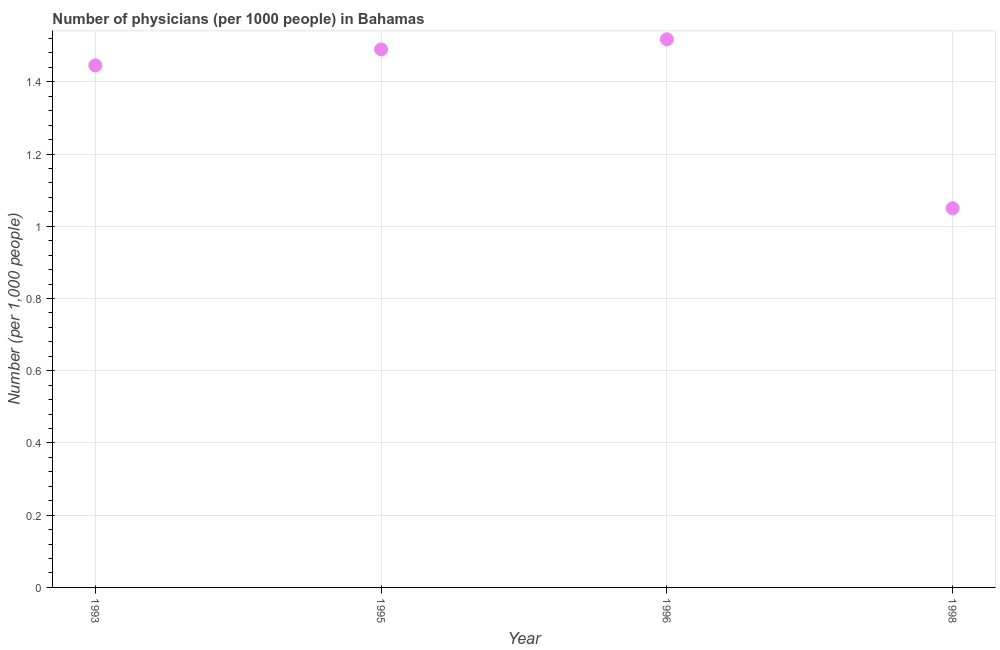What is the number of physicians in 1993?
Offer a terse response. 1.45. Across all years, what is the maximum number of physicians?
Provide a short and direct response. 1.52. What is the sum of the number of physicians?
Offer a terse response. 5.5. What is the difference between the number of physicians in 1993 and 1995?
Make the answer very short. -0.04. What is the average number of physicians per year?
Your response must be concise. 1.38. What is the median number of physicians?
Ensure brevity in your answer.  1.47. In how many years, is the number of physicians greater than 0.52 ?
Your answer should be compact. 4. Do a majority of the years between 1996 and 1998 (inclusive) have number of physicians greater than 0.52 ?
Provide a short and direct response. Yes. What is the ratio of the number of physicians in 1993 to that in 1996?
Make the answer very short. 0.95. Is the difference between the number of physicians in 1995 and 1996 greater than the difference between any two years?
Offer a very short reply. No. What is the difference between the highest and the second highest number of physicians?
Your answer should be compact. 0.03. What is the difference between the highest and the lowest number of physicians?
Your response must be concise. 0.47. How many years are there in the graph?
Offer a terse response. 4. Does the graph contain any zero values?
Provide a succinct answer. No. Does the graph contain grids?
Your answer should be compact. Yes. What is the title of the graph?
Keep it short and to the point. Number of physicians (per 1000 people) in Bahamas. What is the label or title of the X-axis?
Your answer should be very brief. Year. What is the label or title of the Y-axis?
Provide a short and direct response. Number (per 1,0 people). What is the Number (per 1,000 people) in 1993?
Offer a terse response. 1.45. What is the Number (per 1,000 people) in 1995?
Provide a short and direct response. 1.49. What is the Number (per 1,000 people) in 1996?
Make the answer very short. 1.52. What is the Number (per 1,000 people) in 1998?
Provide a succinct answer. 1.05. What is the difference between the Number (per 1,000 people) in 1993 and 1995?
Give a very brief answer. -0.04. What is the difference between the Number (per 1,000 people) in 1993 and 1996?
Ensure brevity in your answer.  -0.07. What is the difference between the Number (per 1,000 people) in 1993 and 1998?
Ensure brevity in your answer.  0.4. What is the difference between the Number (per 1,000 people) in 1995 and 1996?
Make the answer very short. -0.03. What is the difference between the Number (per 1,000 people) in 1995 and 1998?
Your answer should be very brief. 0.44. What is the difference between the Number (per 1,000 people) in 1996 and 1998?
Your answer should be compact. 0.47. What is the ratio of the Number (per 1,000 people) in 1993 to that in 1996?
Your answer should be very brief. 0.95. What is the ratio of the Number (per 1,000 people) in 1993 to that in 1998?
Your answer should be compact. 1.38. What is the ratio of the Number (per 1,000 people) in 1995 to that in 1996?
Ensure brevity in your answer.  0.98. What is the ratio of the Number (per 1,000 people) in 1995 to that in 1998?
Provide a short and direct response. 1.42. What is the ratio of the Number (per 1,000 people) in 1996 to that in 1998?
Your response must be concise. 1.45. 